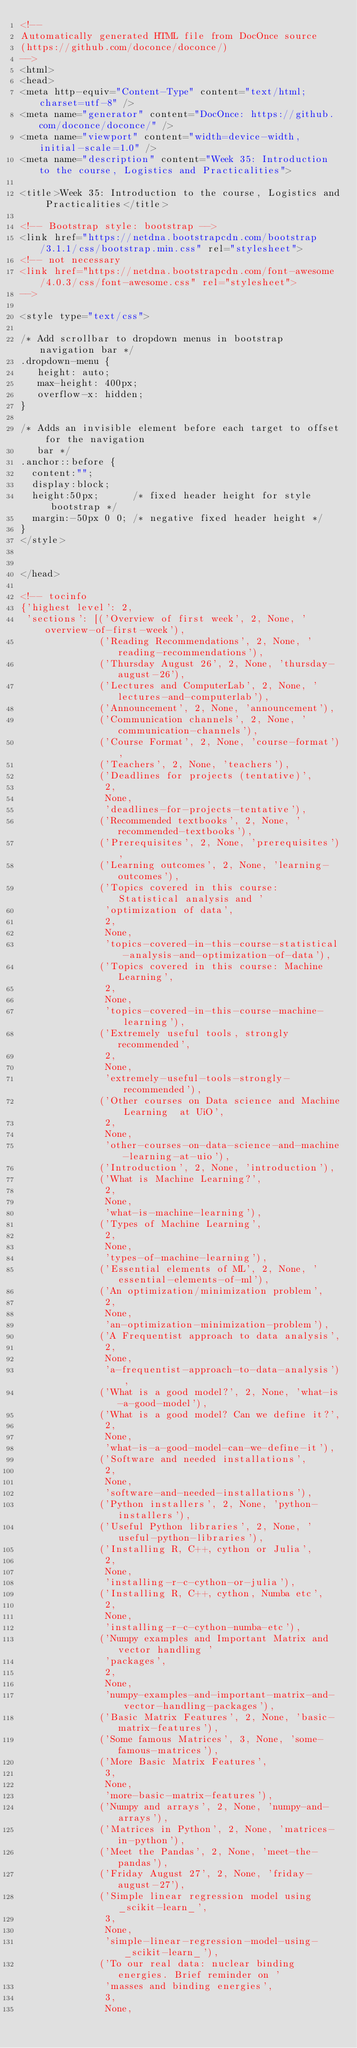Convert code to text. <code><loc_0><loc_0><loc_500><loc_500><_HTML_><!--
Automatically generated HTML file from DocOnce source
(https://github.com/doconce/doconce/)
-->
<html>
<head>
<meta http-equiv="Content-Type" content="text/html; charset=utf-8" />
<meta name="generator" content="DocOnce: https://github.com/doconce/doconce/" />
<meta name="viewport" content="width=device-width, initial-scale=1.0" />
<meta name="description" content="Week 35: Introduction to the course, Logistics and Practicalities">

<title>Week 35: Introduction to the course, Logistics and Practicalities</title>

<!-- Bootstrap style: bootstrap -->
<link href="https://netdna.bootstrapcdn.com/bootstrap/3.1.1/css/bootstrap.min.css" rel="stylesheet">
<!-- not necessary
<link href="https://netdna.bootstrapcdn.com/font-awesome/4.0.3/css/font-awesome.css" rel="stylesheet">
-->

<style type="text/css">

/* Add scrollbar to dropdown menus in bootstrap navigation bar */
.dropdown-menu {
   height: auto;
   max-height: 400px;
   overflow-x: hidden;
}

/* Adds an invisible element before each target to offset for the navigation
   bar */
.anchor::before {
  content:"";
  display:block;
  height:50px;      /* fixed header height for style bootstrap */
  margin:-50px 0 0; /* negative fixed header height */
}
</style>


</head>

<!-- tocinfo
{'highest level': 2,
 'sections': [('Overview of first week', 2, None, 'overview-of-first-week'),
              ('Reading Recommendations', 2, None, 'reading-recommendations'),
              ('Thursday August 26', 2, None, 'thursday-august-26'),
              ('Lectures and ComputerLab', 2, None, 'lectures-and-computerlab'),
              ('Announcement', 2, None, 'announcement'),
              ('Communication channels', 2, None, 'communication-channels'),
              ('Course Format', 2, None, 'course-format'),
              ('Teachers', 2, None, 'teachers'),
              ('Deadlines for projects (tentative)',
               2,
               None,
               'deadlines-for-projects-tentative'),
              ('Recommended textbooks', 2, None, 'recommended-textbooks'),
              ('Prerequisites', 2, None, 'prerequisites'),
              ('Learning outcomes', 2, None, 'learning-outcomes'),
              ('Topics covered in this course: Statistical analysis and '
               'optimization of data',
               2,
               None,
               'topics-covered-in-this-course-statistical-analysis-and-optimization-of-data'),
              ('Topics covered in this course: Machine Learning',
               2,
               None,
               'topics-covered-in-this-course-machine-learning'),
              ('Extremely useful tools, strongly recommended',
               2,
               None,
               'extremely-useful-tools-strongly-recommended'),
              ('Other courses on Data science and Machine Learning  at UiO',
               2,
               None,
               'other-courses-on-data-science-and-machine-learning-at-uio'),
              ('Introduction', 2, None, 'introduction'),
              ('What is Machine Learning?',
               2,
               None,
               'what-is-machine-learning'),
              ('Types of Machine Learning',
               2,
               None,
               'types-of-machine-learning'),
              ('Essential elements of ML', 2, None, 'essential-elements-of-ml'),
              ('An optimization/minimization problem',
               2,
               None,
               'an-optimization-minimization-problem'),
              ('A Frequentist approach to data analysis',
               2,
               None,
               'a-frequentist-approach-to-data-analysis'),
              ('What is a good model?', 2, None, 'what-is-a-good-model'),
              ('What is a good model? Can we define it?',
               2,
               None,
               'what-is-a-good-model-can-we-define-it'),
              ('Software and needed installations',
               2,
               None,
               'software-and-needed-installations'),
              ('Python installers', 2, None, 'python-installers'),
              ('Useful Python libraries', 2, None, 'useful-python-libraries'),
              ('Installing R, C++, cython or Julia',
               2,
               None,
               'installing-r-c-cython-or-julia'),
              ('Installing R, C++, cython, Numba etc',
               2,
               None,
               'installing-r-c-cython-numba-etc'),
              ('Numpy examples and Important Matrix and vector handling '
               'packages',
               2,
               None,
               'numpy-examples-and-important-matrix-and-vector-handling-packages'),
              ('Basic Matrix Features', 2, None, 'basic-matrix-features'),
              ('Some famous Matrices', 3, None, 'some-famous-matrices'),
              ('More Basic Matrix Features',
               3,
               None,
               'more-basic-matrix-features'),
              ('Numpy and arrays', 2, None, 'numpy-and-arrays'),
              ('Matrices in Python', 2, None, 'matrices-in-python'),
              ('Meet the Pandas', 2, None, 'meet-the-pandas'),
              ('Friday August 27', 2, None, 'friday-august-27'),
              ('Simple linear regression model using _scikit-learn_',
               3,
               None,
               'simple-linear-regression-model-using-_scikit-learn_'),
              ('To our real data: nuclear binding energies. Brief reminder on '
               'masses and binding energies',
               3,
               None,</code> 